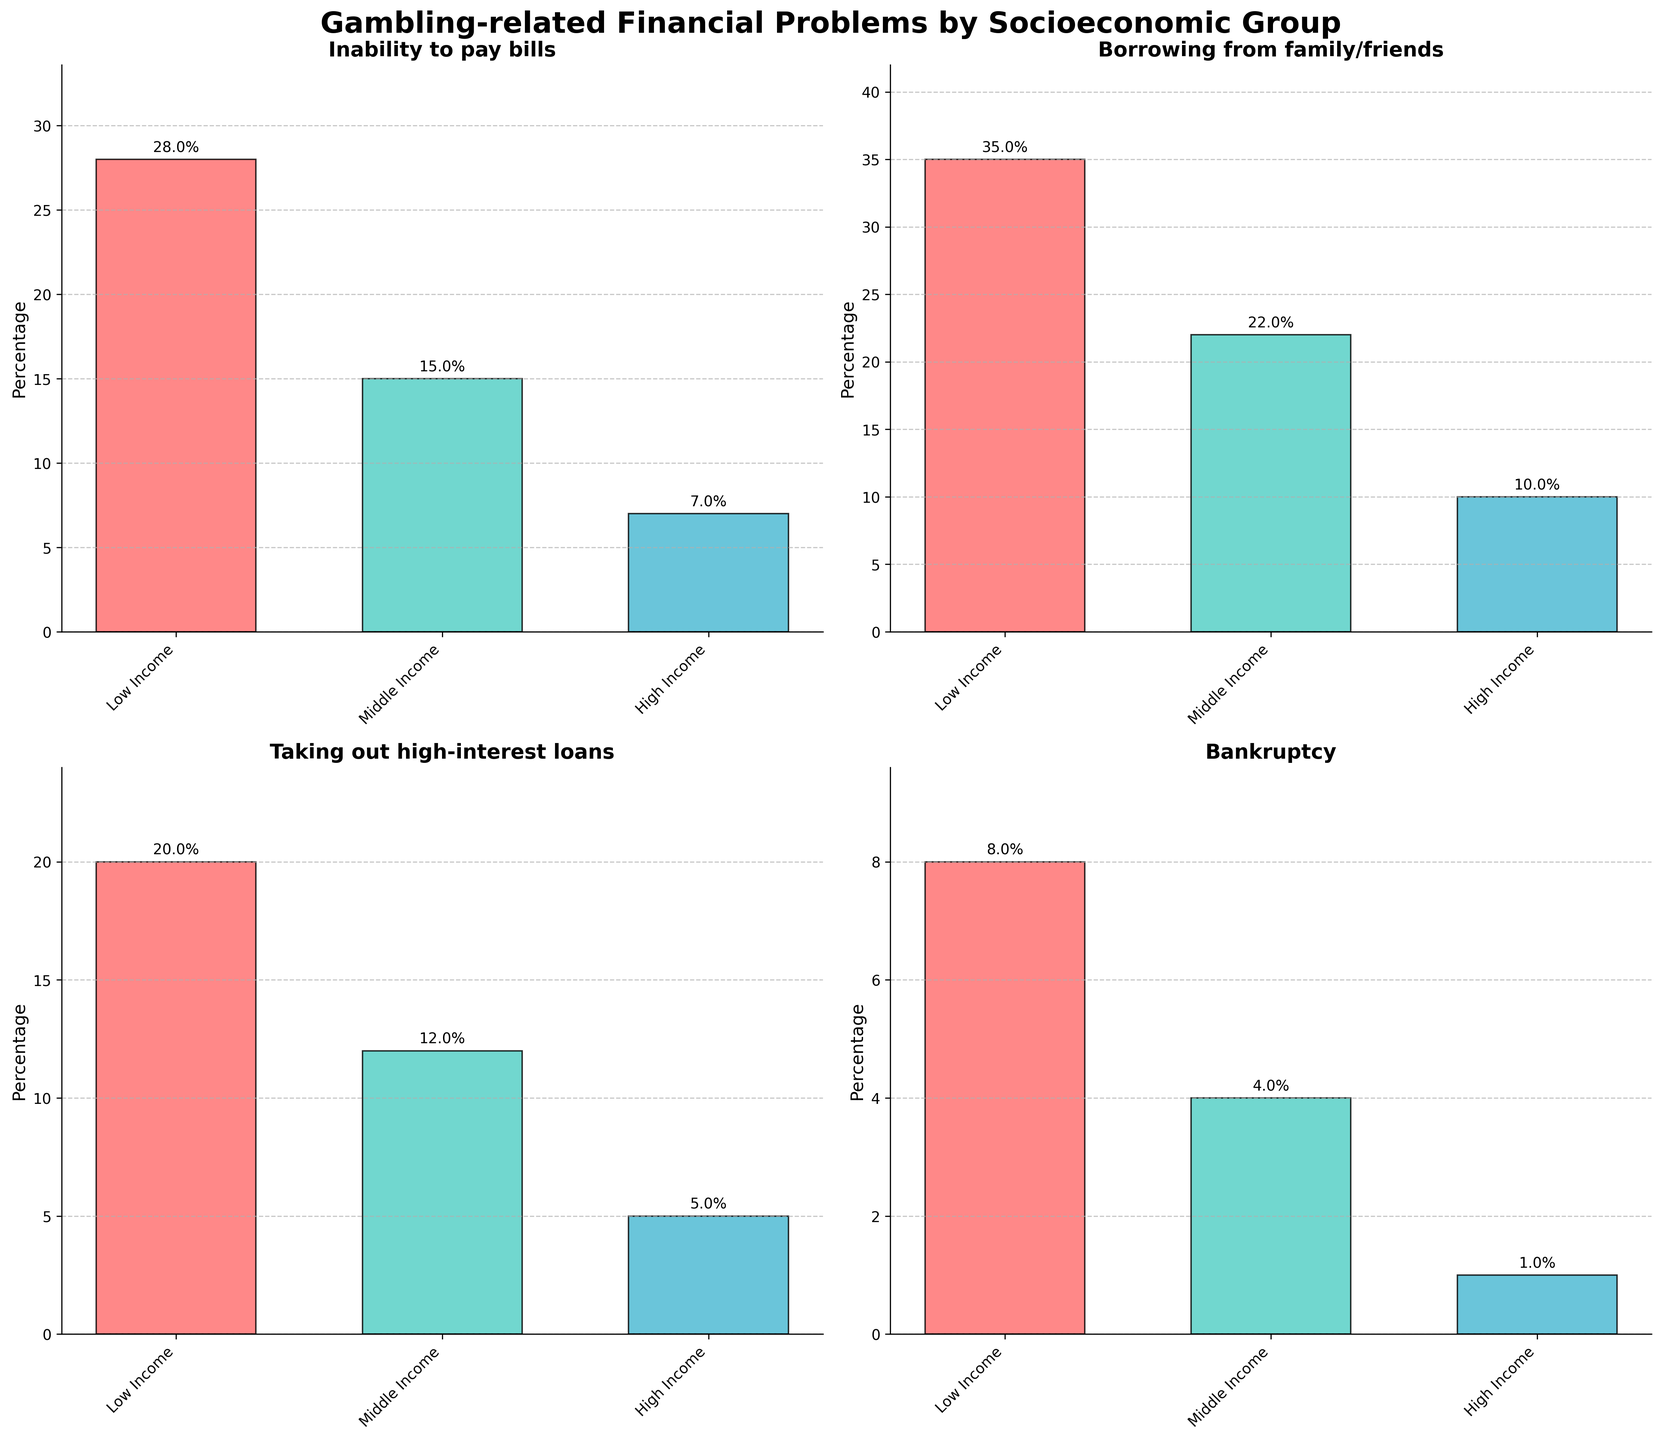In the subplot for 'Inability to pay bills', what percentage of high-income individuals experience this problem? The subplot for 'Inability to pay bills' shows three bars representing low, middle, and high-income groups. The bar for the high-income group is labeled with its height, which indicates the percentage. By observing this label, we can see that the percentage for high-income individuals is 7%.
Answer: 7% In the subplot for 'Borrowing from family/friends', which socioeconomic group has the highest percentage, and what is that percentage? In the subplot for 'Borrowing from family/friends', three bars represent the percentages for low, middle, and high-income groups. By comparing the heights of these bars, we see that the low-income group has the highest bar, indicating the highest percentage. The annotated label on this bar shows that the percentage is 35%.
Answer: Low income, 35% Considering the subplots for 'Taking out high-interest loans' and 'Selling personal assets', what is the combined percentage of middle-income individuals experiencing these problems? To find the combined percentage, we need to add the percentages of middle-income individuals from both subplots. In 'Taking out high-interest loans', the percentage is 12%. In 'Selling personal assets', the percentage is 9%. Adding these together, we get 12% + 9% = 21%.
Answer: 21% In the subplot for 'Credit card debt', compare the percentages of middle-income individuals and high-income individuals. What is the difference? The subplot for 'Credit card debt' features three bars for low, middle, and high-income groups. We find the percentages for the middle and high-income groups by looking at the heights of their respective bars. The middle-income percentage is 25%, and the high-income percentage is 14%. The difference is calculated as 25% - 14% = 11%.
Answer: 11% How does the percentage of low-income individuals facing mortgage defaults compare with the percentage of high-income individuals facing the same problem? In the subplot for 'Mortgage defaults', we observe the bars representing low- and high-income groups. The height of the bar for low-income individuals indicates 12%, and for high-income individuals, it shows 2%. By comparing these percentages, we see that the percentage for low-income individuals is higher by 12% - 2% = 10%.
Answer: Low income is higher by 10% What is the average percentage of gambling-related financial problems across all socioeconomic groups for 'Bankruptcy'? The subplot for 'Bankruptcy' displays the percentages for each socioeconomic group. The percentages are 8% for low-income, 4% for middle-income, and 1% for high-income. To find the average, we sum these percentages and divide by the number of groups: (8% + 4% + 1%) / 3 = 13% / 3 ≈ 4.33%.
Answer: 4.33% Which gambling-related financial problem has the highest percentage for the middle-income group, and what is that percentage? To answer this, we look at all subplots and note the middle-income percentages. The highest percentage among them is for 'Credit card debt' at 25%.
Answer: Credit card debt, 25% What is the range of percentages for the 'Taking out high-interest loans' problem across the three socioeconomic groups? In the subplot for 'Taking out high-interest loans', the percentages are 20% for low-income, 12% for middle-income, and 5% for high-income groups. The range is calculated as the difference between the highest and lowest percentages: 20% - 5% = 15%.
Answer: 15% For which gambling-related financial problem is the disparity between low and high-income groups the largest, and what is that disparity? We need to compare the differences between the low-income and high-income groups' percentages for each problem. The largest disparity is found in 'Borrowing from family/friends', where the percentage difference is 35% (low-income) - 10% (high-income) = 25%.
Answer: Borrowing from family/friends, 25% 